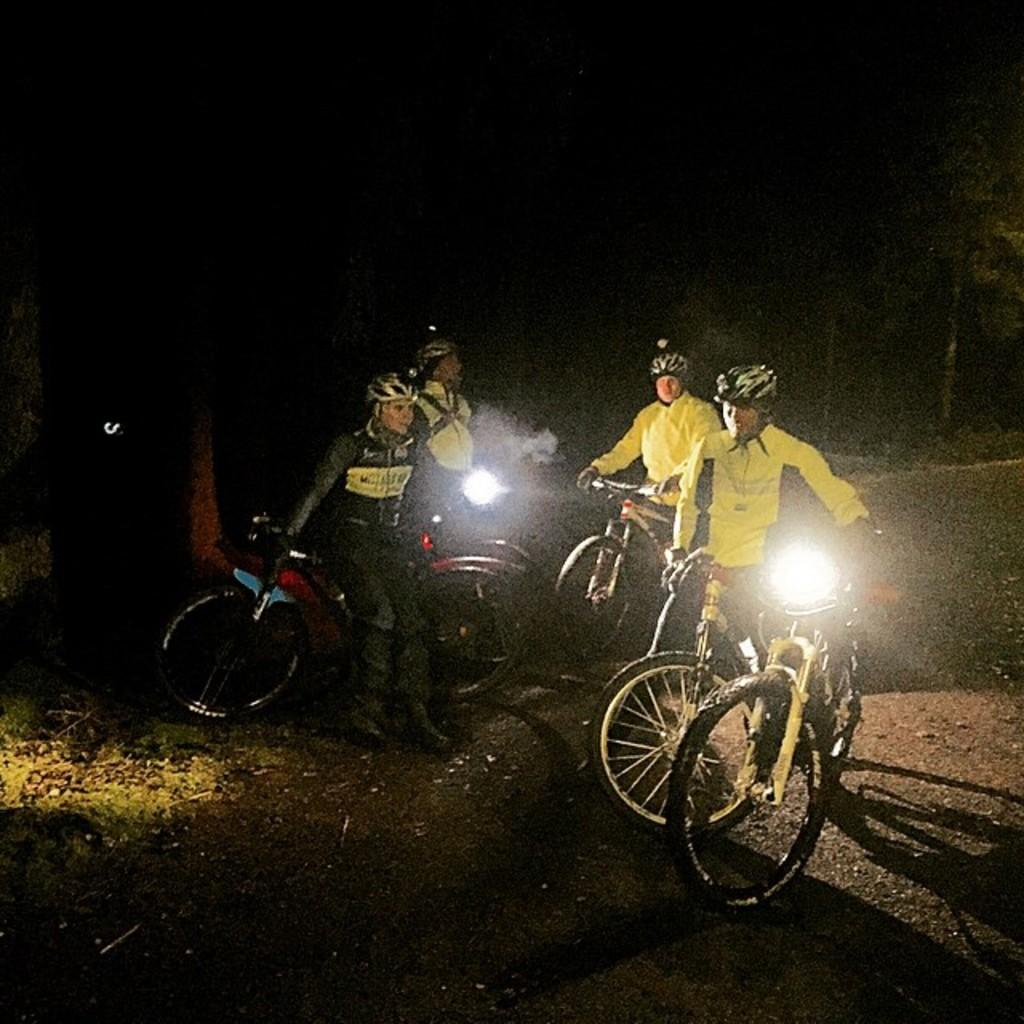How many people are in the image? There are four persons in the image. What are the persons doing in the image? The persons are riding bicycles. Where are the bicycles located in the image? The bicycles are on the ground. What can be seen in the background of the image? There is grass and trees in the background of the image. Can you describe the lighting conditions in the image? The image may have been taken during nighttime, as it appears to be dark. What type of payment is required to ride the bicycles in the image? There is no indication in the image that any payment is required to ride the bicycles. What is the cause of the trees in the background of the image? The trees in the background of the image are a natural part of the environment and do not have a specific cause. 